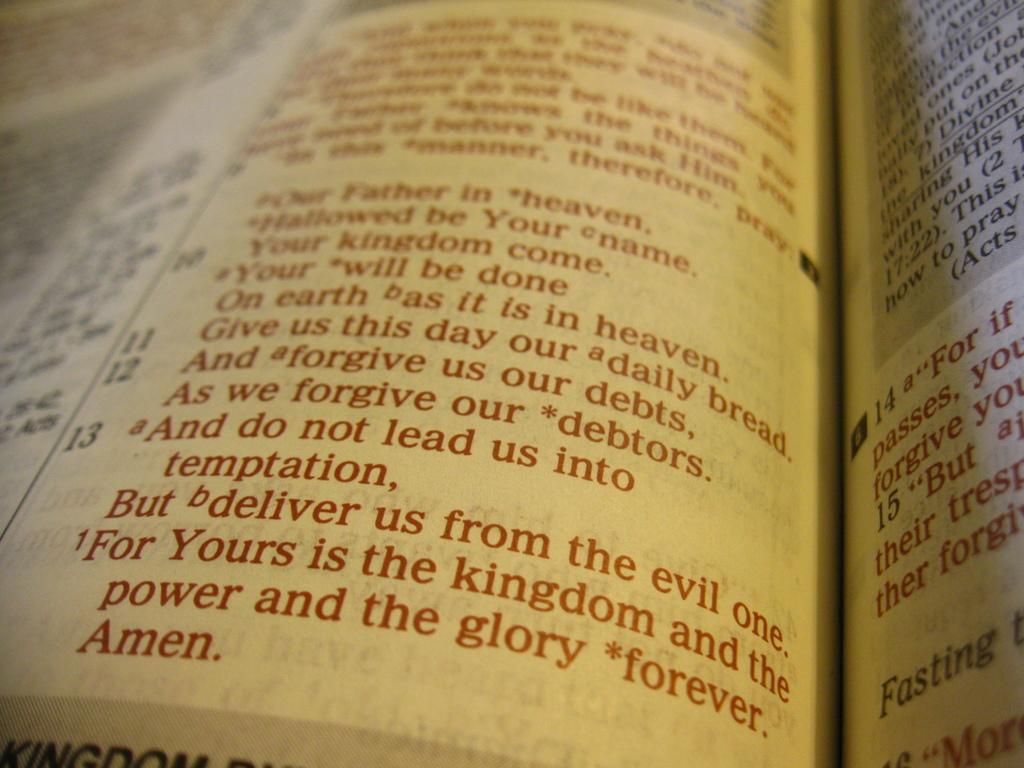With what word does the featured prayer end?
Provide a short and direct response. Amen. What word is in bold letters to the right?
Provide a short and direct response. Fasting. 